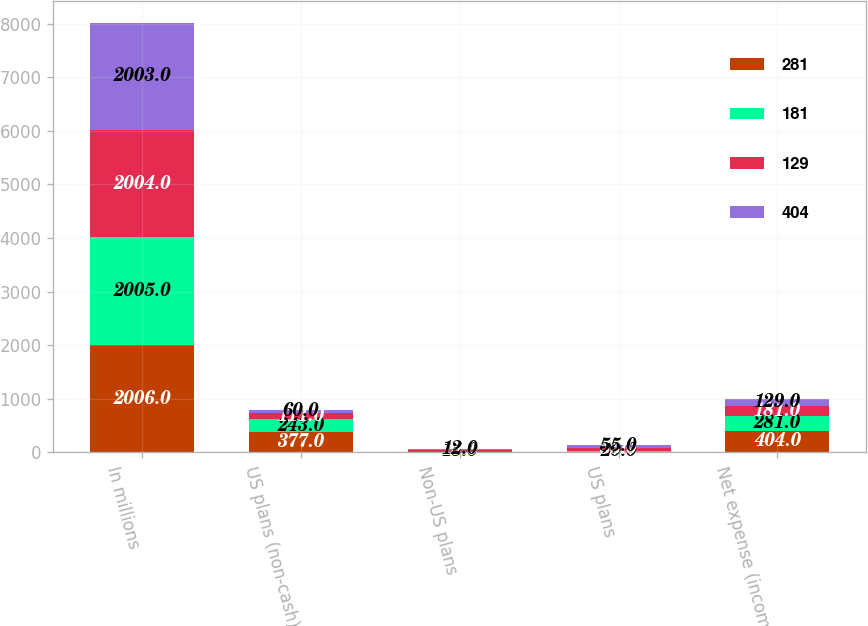Convert chart to OTSL. <chart><loc_0><loc_0><loc_500><loc_500><stacked_bar_chart><ecel><fcel>In millions<fcel>US plans (non-cash)<fcel>Non-US plans<fcel>US plans<fcel>Net expense (income)<nl><fcel>281<fcel>2006<fcel>377<fcel>17<fcel>7<fcel>404<nl><fcel>181<fcel>2005<fcel>243<fcel>15<fcel>20<fcel>281<nl><fcel>129<fcel>2004<fcel>111<fcel>15<fcel>53<fcel>181<nl><fcel>404<fcel>2003<fcel>60<fcel>12<fcel>55<fcel>129<nl></chart> 